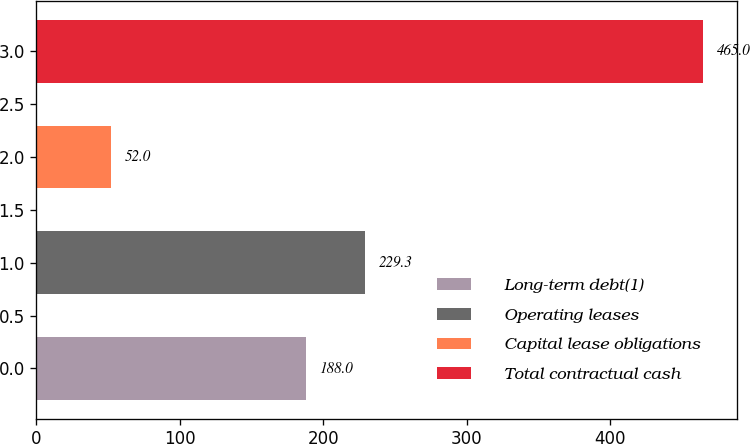<chart> <loc_0><loc_0><loc_500><loc_500><bar_chart><fcel>Long-term debt(1)<fcel>Operating leases<fcel>Capital lease obligations<fcel>Total contractual cash<nl><fcel>188<fcel>229.3<fcel>52<fcel>465<nl></chart> 